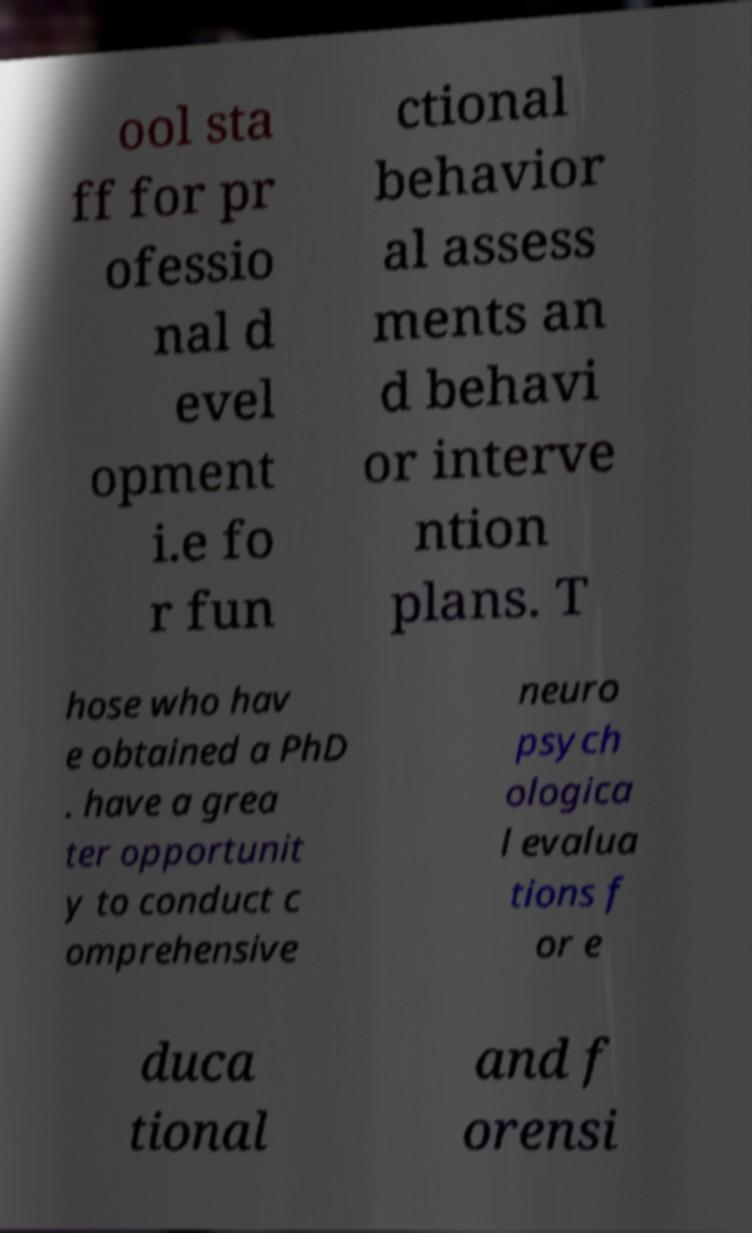Can you read and provide the text displayed in the image?This photo seems to have some interesting text. Can you extract and type it out for me? ool sta ff for pr ofessio nal d evel opment i.e fo r fun ctional behavior al assess ments an d behavi or interve ntion plans. T hose who hav e obtained a PhD . have a grea ter opportunit y to conduct c omprehensive neuro psych ologica l evalua tions f or e duca tional and f orensi 